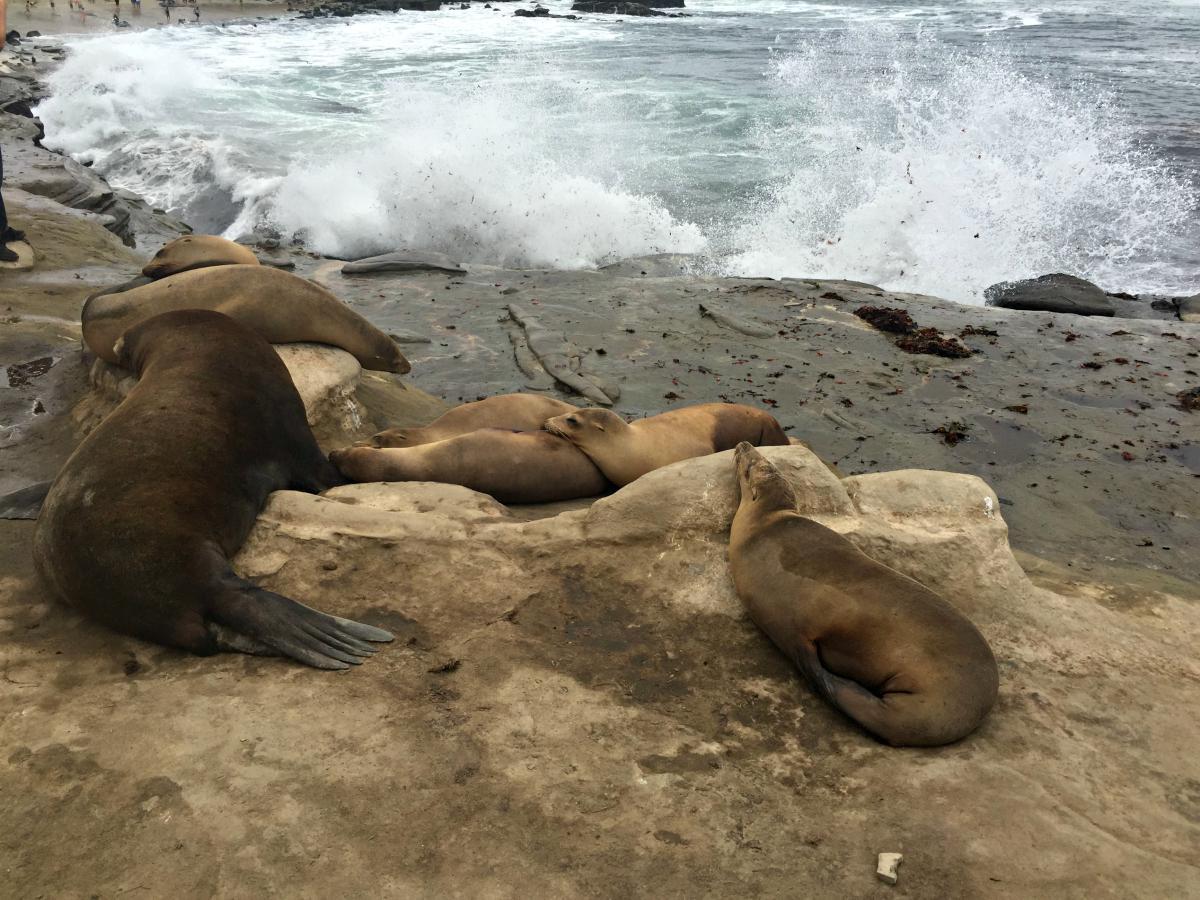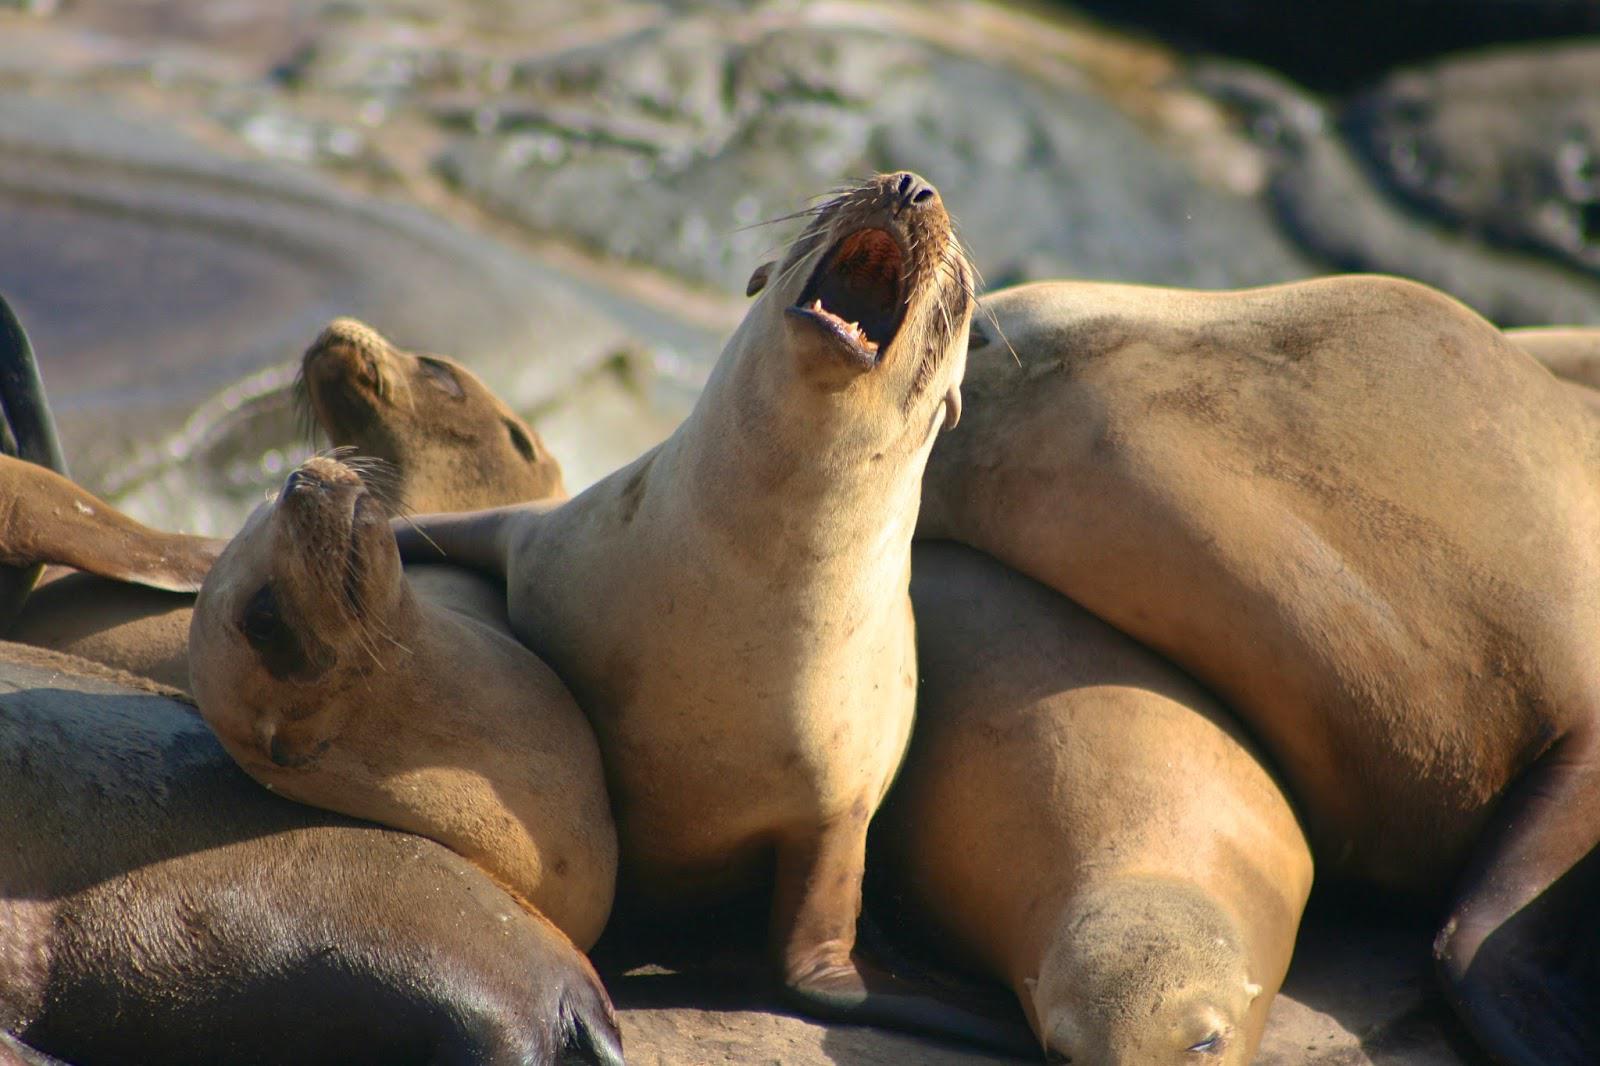The first image is the image on the left, the second image is the image on the right. Analyze the images presented: Is the assertion "There is water in the image on the left." valid? Answer yes or no. Yes. The first image is the image on the left, the second image is the image on the right. Examine the images to the left and right. Is the description "Right image shows one large mail seal and several small females." accurate? Answer yes or no. No. 